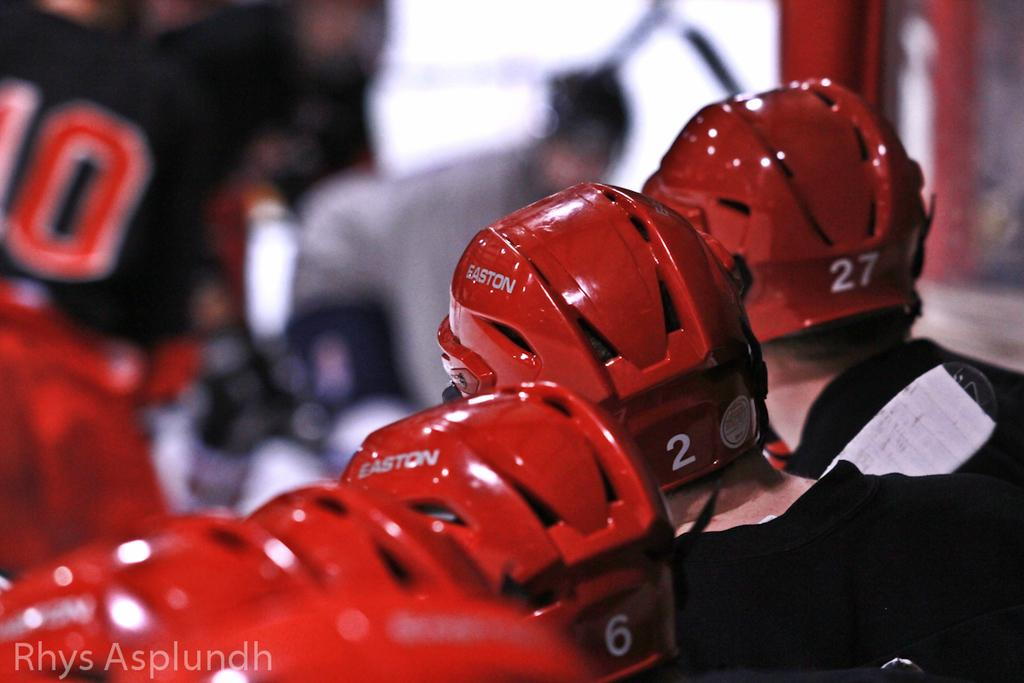Who or what is present in the image? There are people in the image. What are the people wearing on their heads? The people are wearing helmets. Can you describe the background of the image? The background of the image is blurry. What type of shoes are the people wearing on their toes in the image? There is no information about the type of shoes or the toes of the people in the image. 